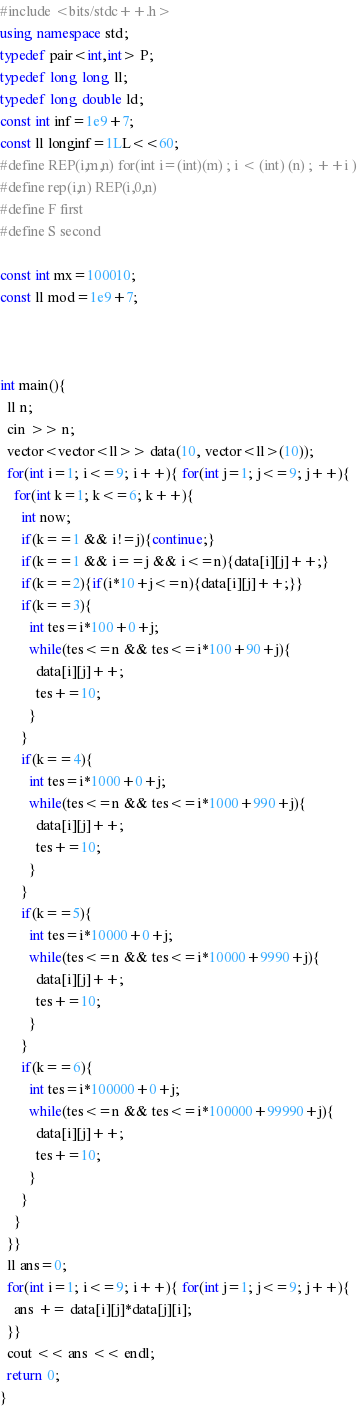Convert code to text. <code><loc_0><loc_0><loc_500><loc_500><_C++_>#include <bits/stdc++.h>
using namespace std;
typedef pair<int,int> P;
typedef long long ll;
typedef long double ld;
const int inf=1e9+7;
const ll longinf=1LL<<60;
#define REP(i,m,n) for(int i=(int)(m) ; i < (int) (n) ; ++i )
#define rep(i,n) REP(i,0,n)
#define F first
#define S second
 
const int mx=100010;
const ll mod=1e9+7;



int main(){
  ll n;
  cin >> n;
  vector<vector<ll>> data(10, vector<ll>(10));
  for(int i=1; i<=9; i++){ for(int j=1; j<=9; j++){
    for(int k=1; k<=6; k++){
      int now;
      if(k==1 && i!=j){continue;}
      if(k==1 && i==j && i<=n){data[i][j]++;}
      if(k==2){if(i*10+j<=n){data[i][j]++;}}
      if(k==3){
        int tes=i*100+0+j;
        while(tes<=n && tes<=i*100+90+j){
          data[i][j]++;
          tes+=10;
        }
      }
      if(k==4){
        int tes=i*1000+0+j;
        while(tes<=n && tes<=i*1000+990+j){
          data[i][j]++;
          tes+=10;
        }
      }
      if(k==5){
        int tes=i*10000+0+j;
        while(tes<=n && tes<=i*10000+9990+j){
          data[i][j]++;
          tes+=10;
        }
      }
      if(k==6){
        int tes=i*100000+0+j;
        while(tes<=n && tes<=i*100000+99990+j){
          data[i][j]++;
          tes+=10;
        }
      }
    }
  }}
  ll ans=0;
  for(int i=1; i<=9; i++){ for(int j=1; j<=9; j++){
    ans += data[i][j]*data[j][i];
  }}
  cout << ans << endl;
  return 0;
}</code> 